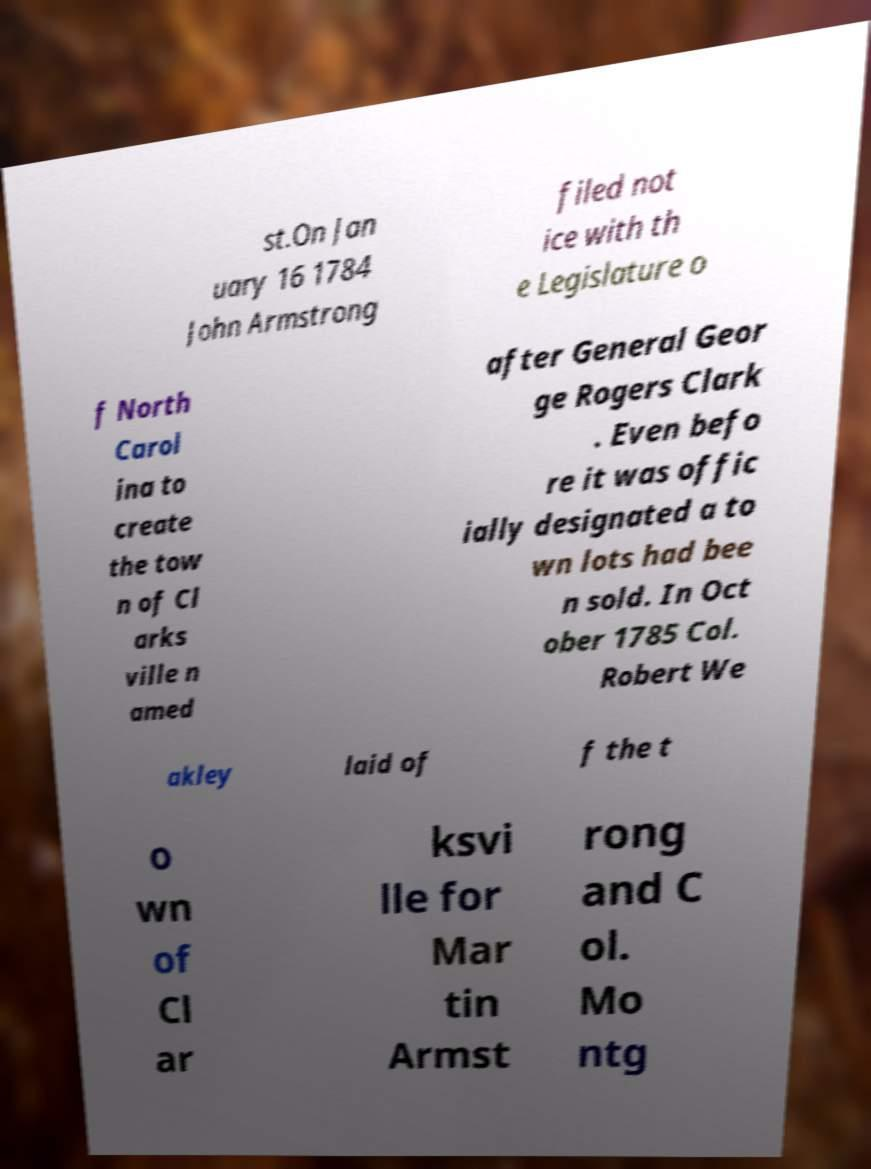What messages or text are displayed in this image? I need them in a readable, typed format. st.On Jan uary 16 1784 John Armstrong filed not ice with th e Legislature o f North Carol ina to create the tow n of Cl arks ville n amed after General Geor ge Rogers Clark . Even befo re it was offic ially designated a to wn lots had bee n sold. In Oct ober 1785 Col. Robert We akley laid of f the t o wn of Cl ar ksvi lle for Mar tin Armst rong and C ol. Mo ntg 